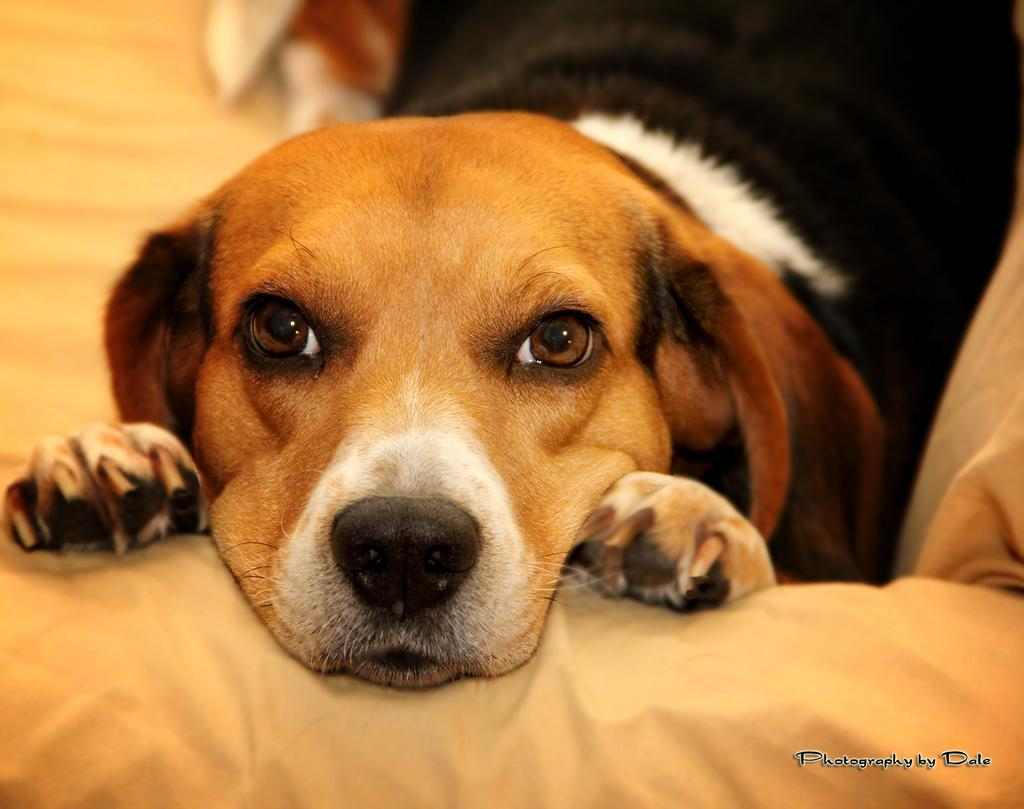What type of animal is in the image? There is a dog in the image. What is the dog doing in the image? The dog is laying on the couch. Can you describe the dog's coloring? The dog has brown and black coloring. What color is the couch the dog is laying on? The couch is cream-colored. What type of pancake is the dog eating in the image? There is no pancake present in the image; the dog is laying on the couch. How does the dog use magic to change the color of the couch in the image? There is no magic or change of color in the image; the couch remains cream-colored. 